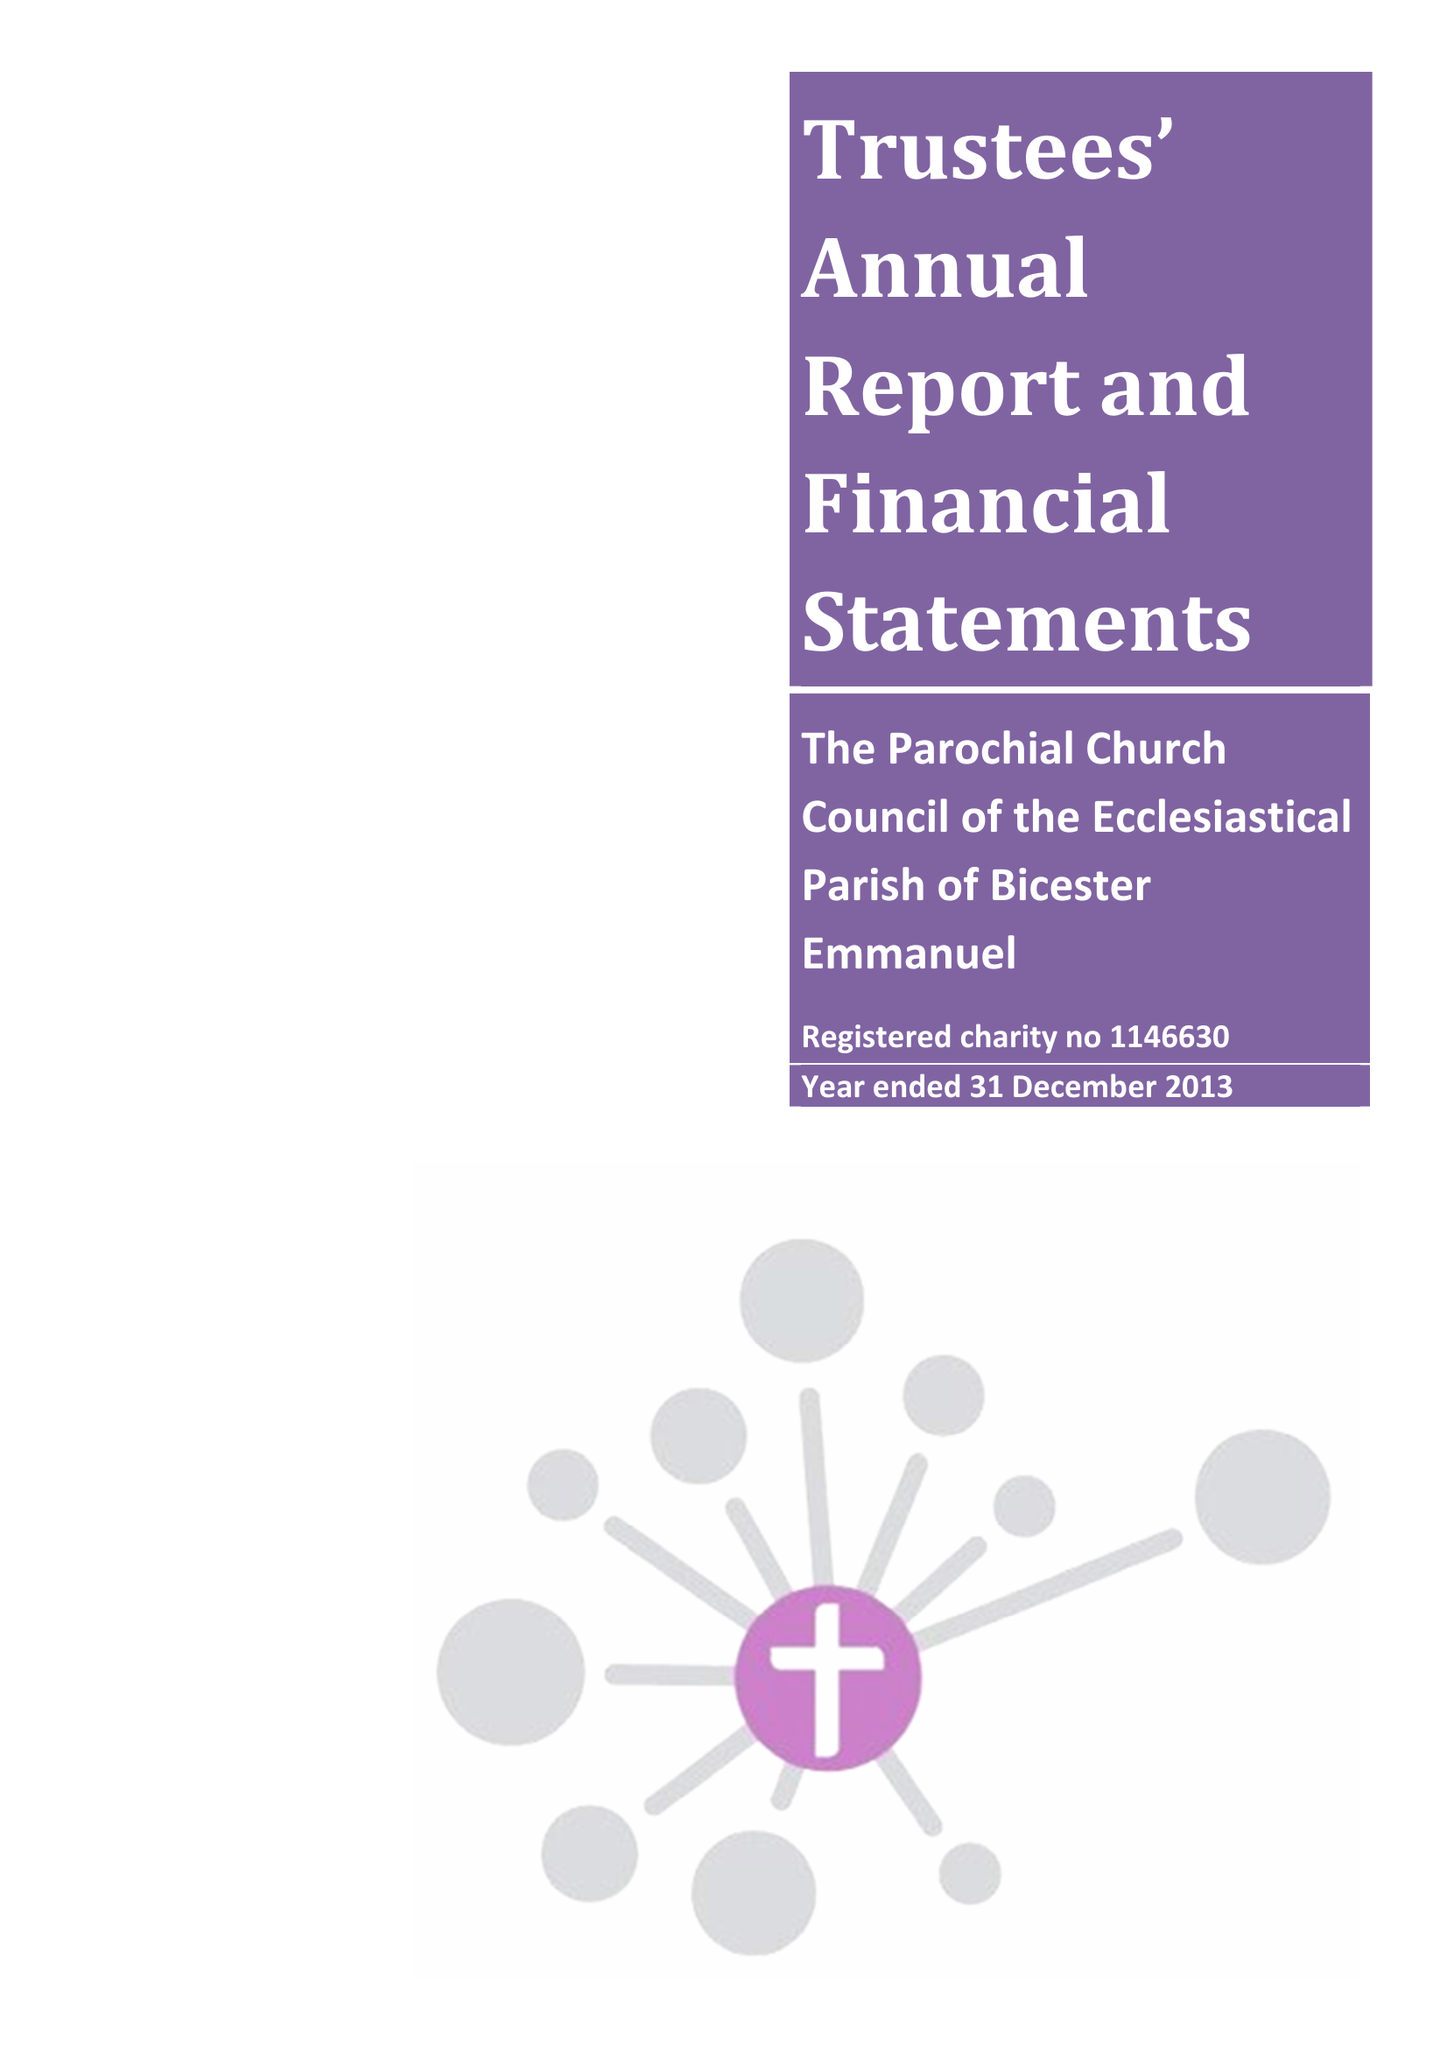What is the value for the address__postcode?
Answer the question using a single word or phrase. OX26 3HA 